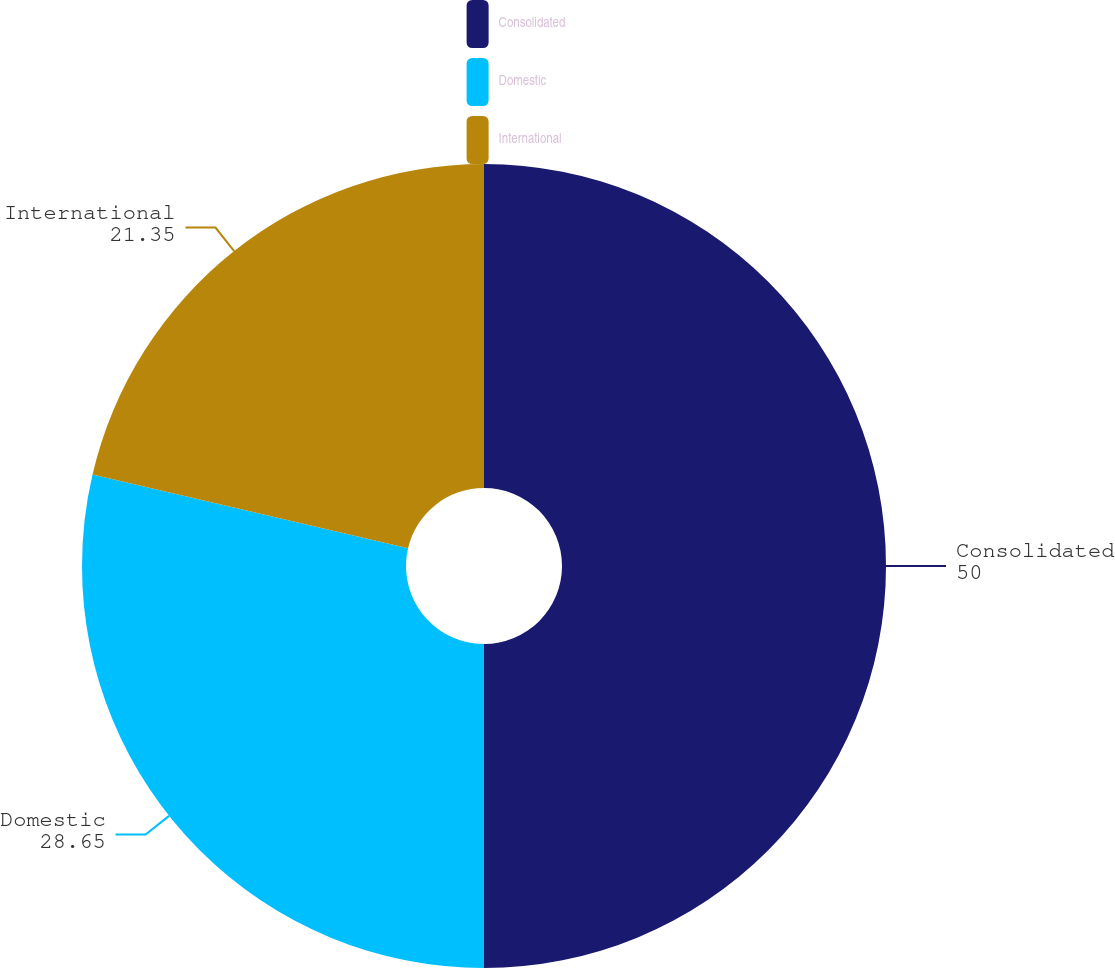Convert chart to OTSL. <chart><loc_0><loc_0><loc_500><loc_500><pie_chart><fcel>Consolidated<fcel>Domestic<fcel>International<nl><fcel>50.0%<fcel>28.65%<fcel>21.35%<nl></chart> 